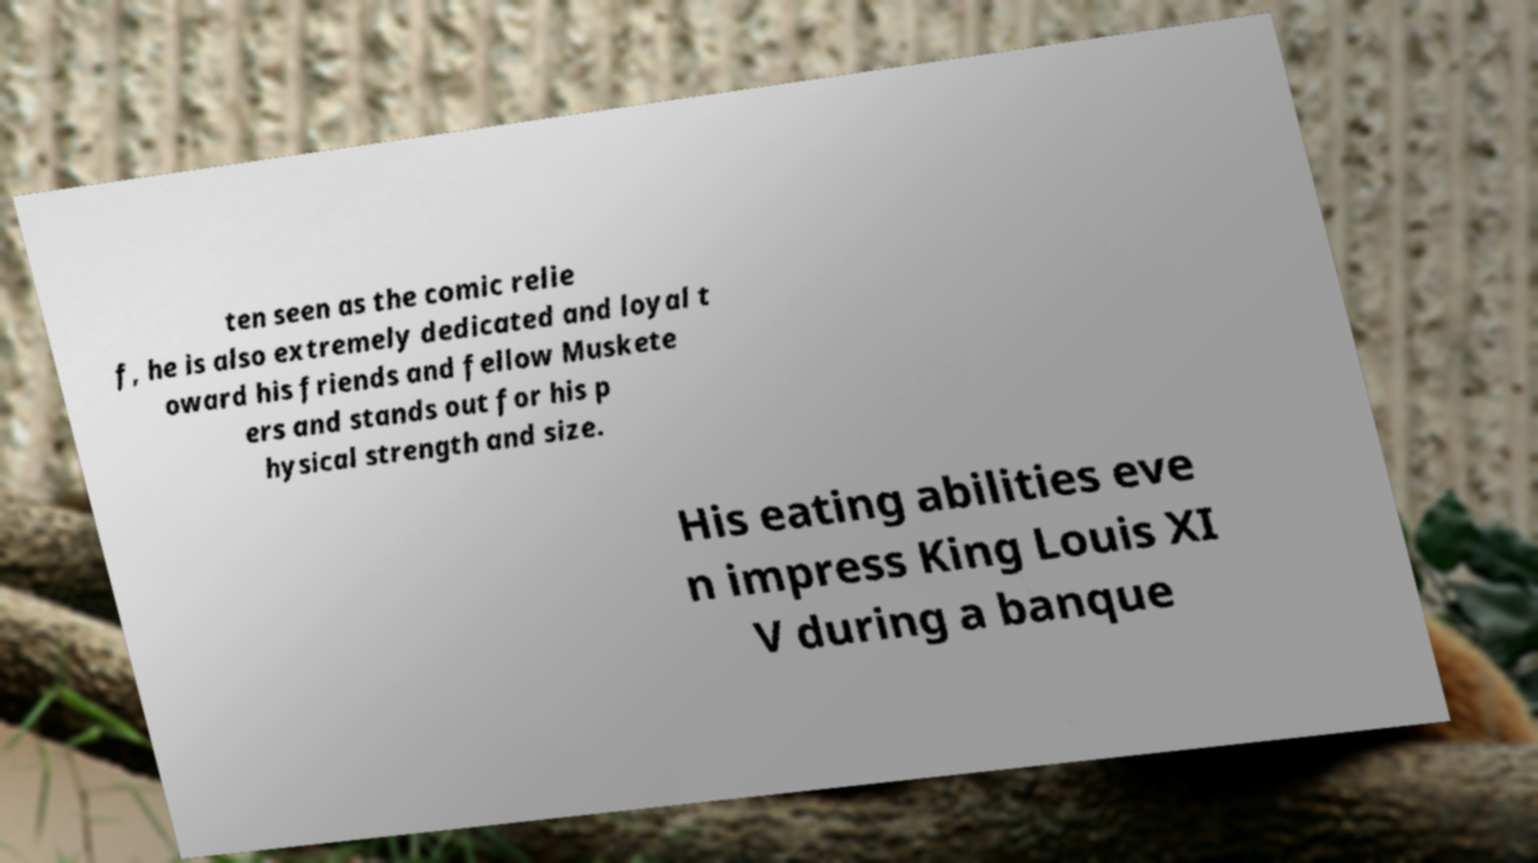Can you read and provide the text displayed in the image?This photo seems to have some interesting text. Can you extract and type it out for me? ten seen as the comic relie f, he is also extremely dedicated and loyal t oward his friends and fellow Muskete ers and stands out for his p hysical strength and size. His eating abilities eve n impress King Louis XI V during a banque 